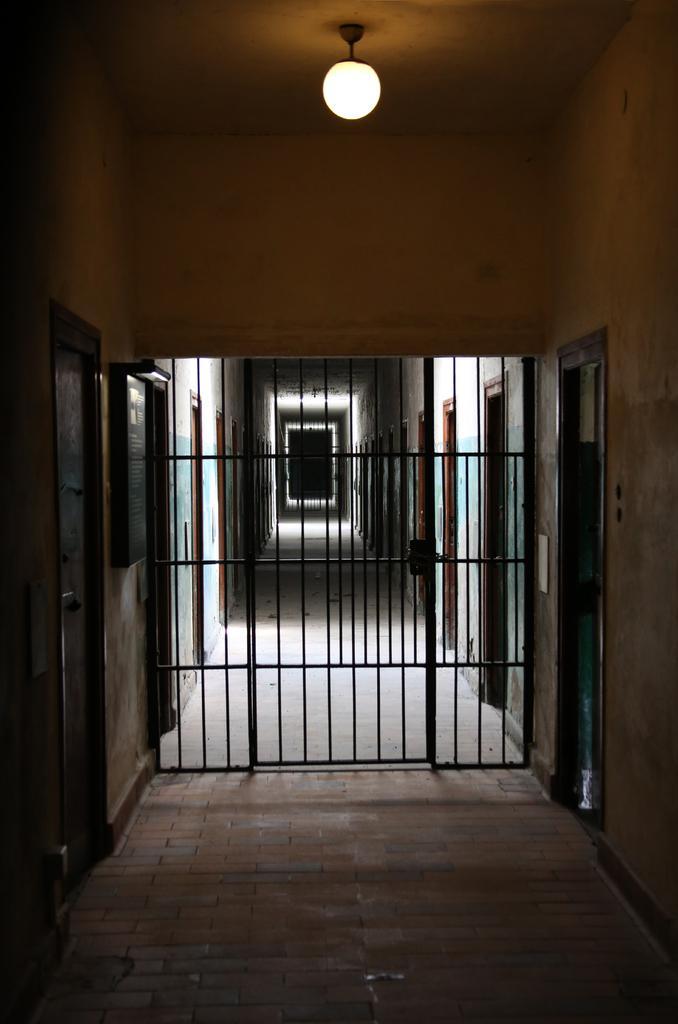Describe this image in one or two sentences. In this picture we can see the floor, gate, doors, frame on the wall, roof and the light. 